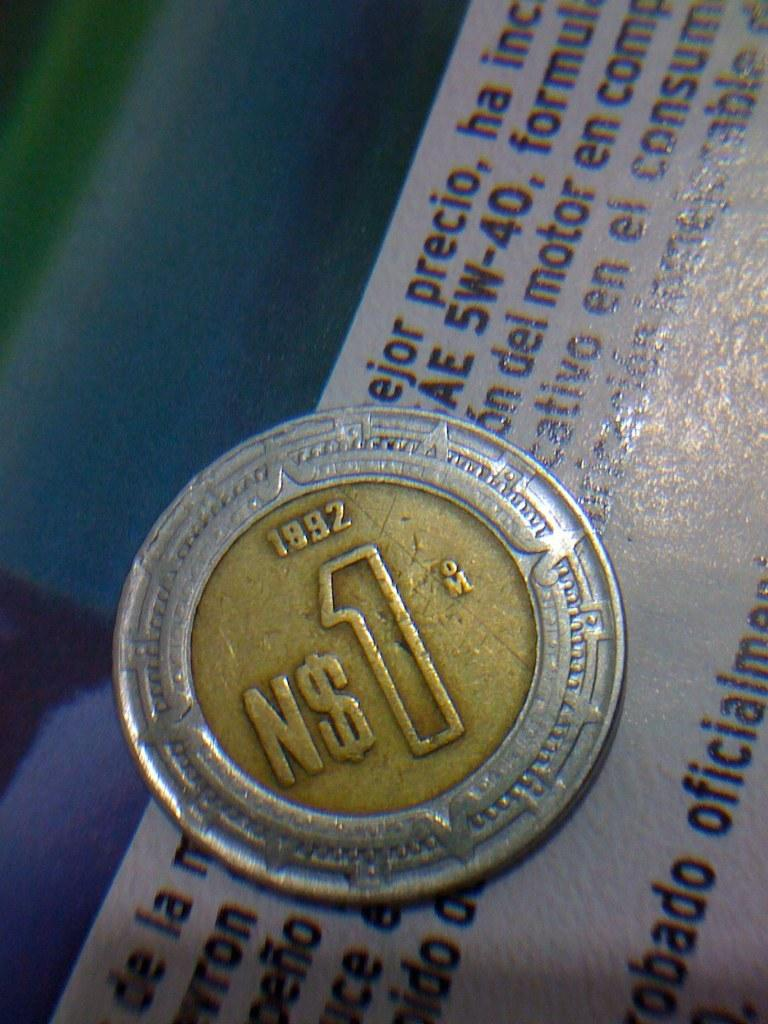<image>
Summarize the visual content of the image. An 1892 coin with a gold center and a silver edge. 